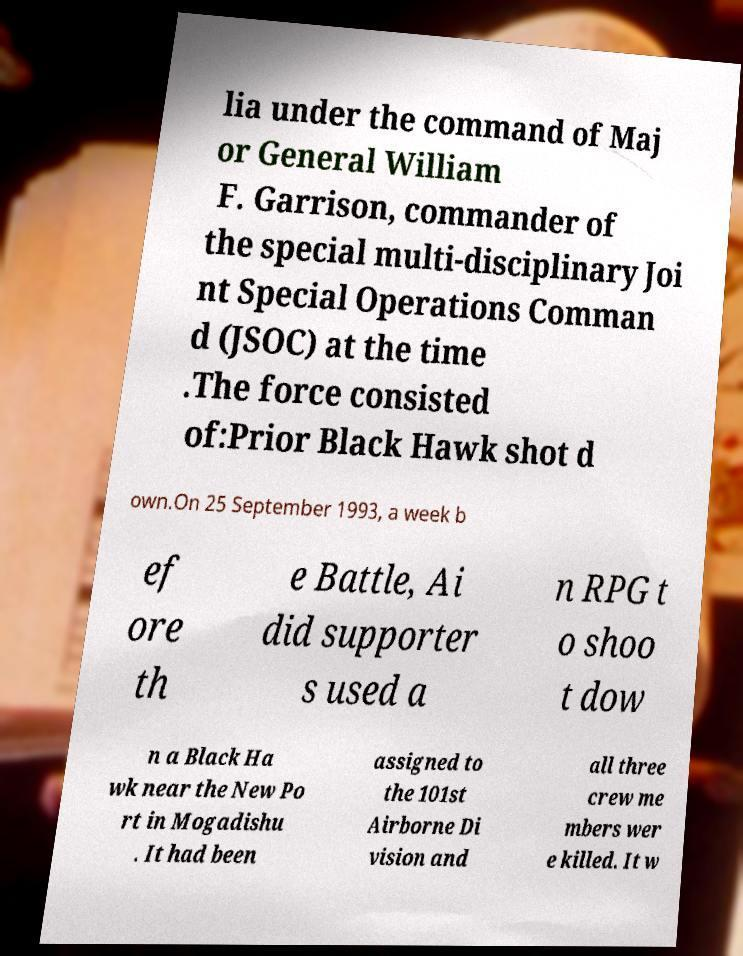For documentation purposes, I need the text within this image transcribed. Could you provide that? lia under the command of Maj or General William F. Garrison, commander of the special multi-disciplinary Joi nt Special Operations Comman d (JSOC) at the time .The force consisted of:Prior Black Hawk shot d own.On 25 September 1993, a week b ef ore th e Battle, Ai did supporter s used a n RPG t o shoo t dow n a Black Ha wk near the New Po rt in Mogadishu . It had been assigned to the 101st Airborne Di vision and all three crew me mbers wer e killed. It w 